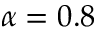<formula> <loc_0><loc_0><loc_500><loc_500>\alpha = 0 . 8</formula> 